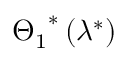<formula> <loc_0><loc_0><loc_500><loc_500>{ { \Theta _ { 1 } } ^ { * } } \left ( { { \lambda } ^ { * } } \right )</formula> 